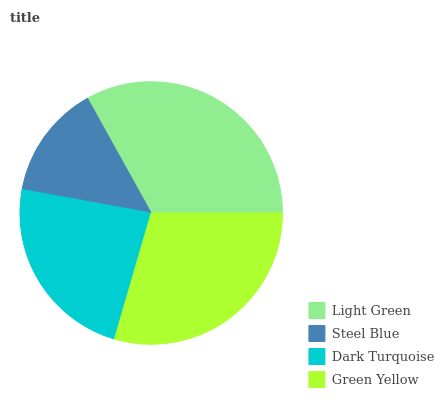Is Steel Blue the minimum?
Answer yes or no. Yes. Is Light Green the maximum?
Answer yes or no. Yes. Is Dark Turquoise the minimum?
Answer yes or no. No. Is Dark Turquoise the maximum?
Answer yes or no. No. Is Dark Turquoise greater than Steel Blue?
Answer yes or no. Yes. Is Steel Blue less than Dark Turquoise?
Answer yes or no. Yes. Is Steel Blue greater than Dark Turquoise?
Answer yes or no. No. Is Dark Turquoise less than Steel Blue?
Answer yes or no. No. Is Green Yellow the high median?
Answer yes or no. Yes. Is Dark Turquoise the low median?
Answer yes or no. Yes. Is Dark Turquoise the high median?
Answer yes or no. No. Is Green Yellow the low median?
Answer yes or no. No. 